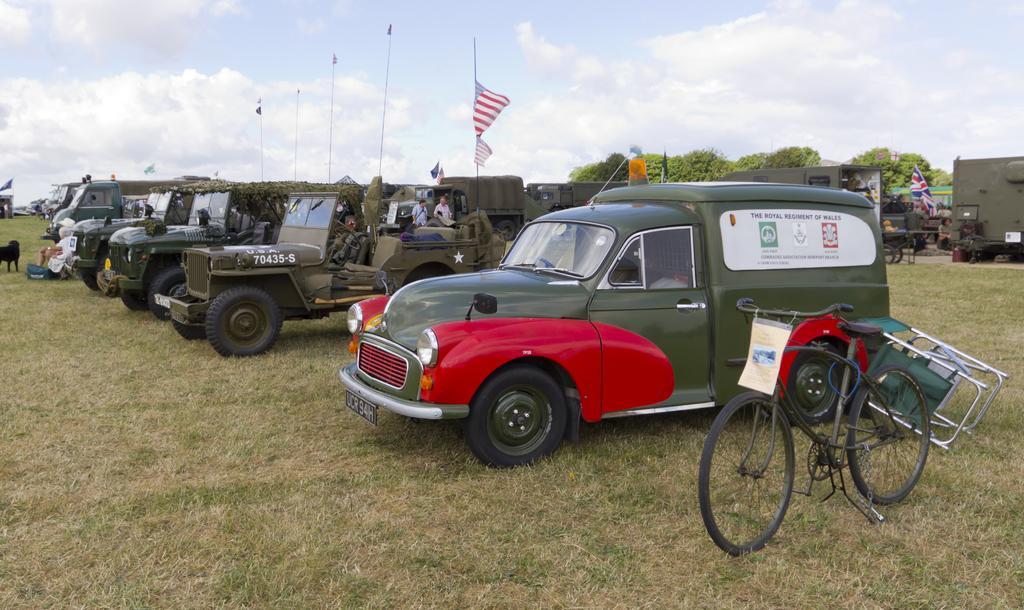Please provide a concise description of this image. In this image I can see many vehicles are on the ground. To the side there is a bicycle. To the left I can see an animal which is in black color. I can also see few people in-front of the vehicles. In the back I can see flags, trees, clouds and the sky. 